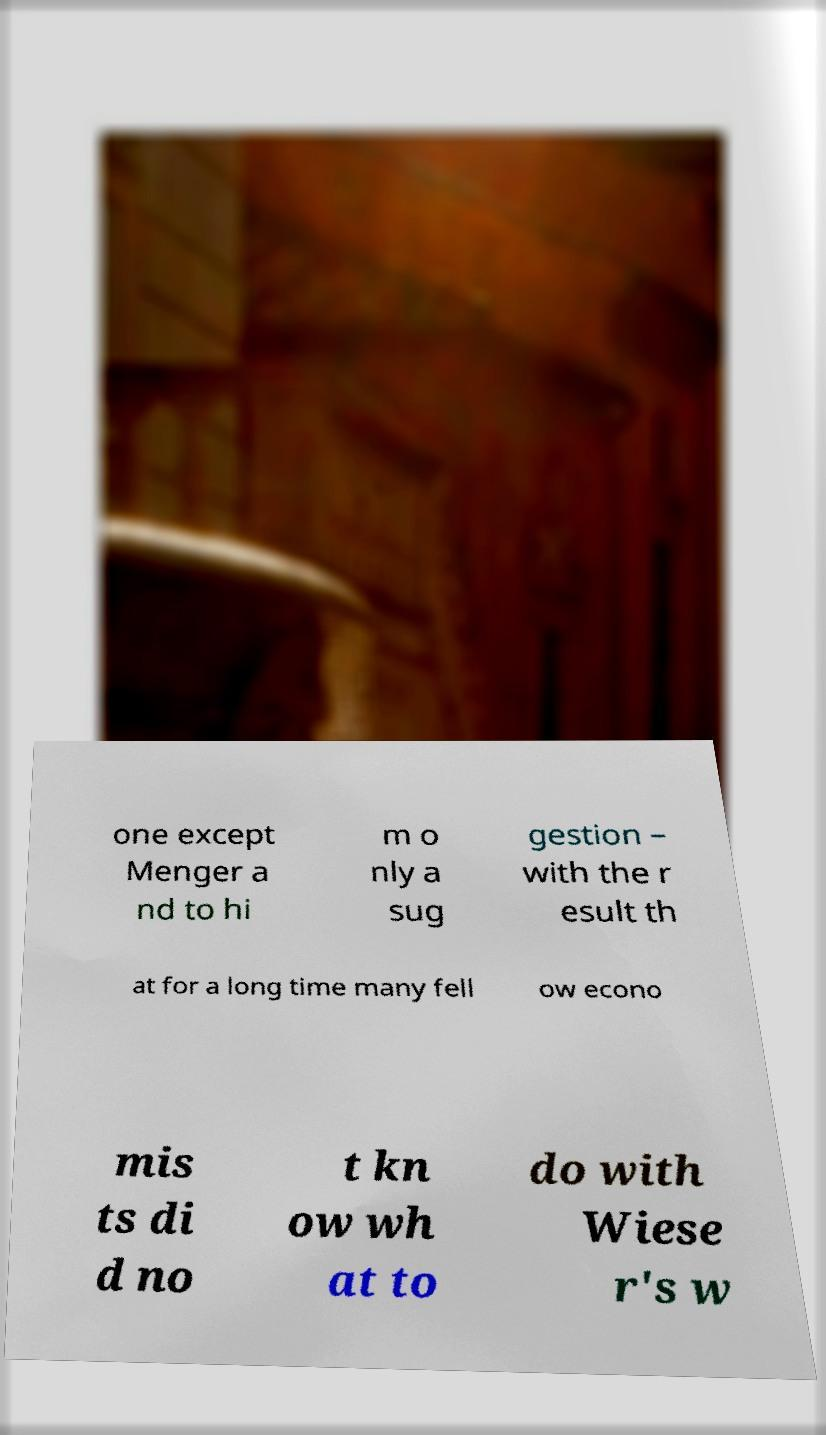For documentation purposes, I need the text within this image transcribed. Could you provide that? one except Menger a nd to hi m o nly a sug gestion – with the r esult th at for a long time many fell ow econo mis ts di d no t kn ow wh at to do with Wiese r's w 